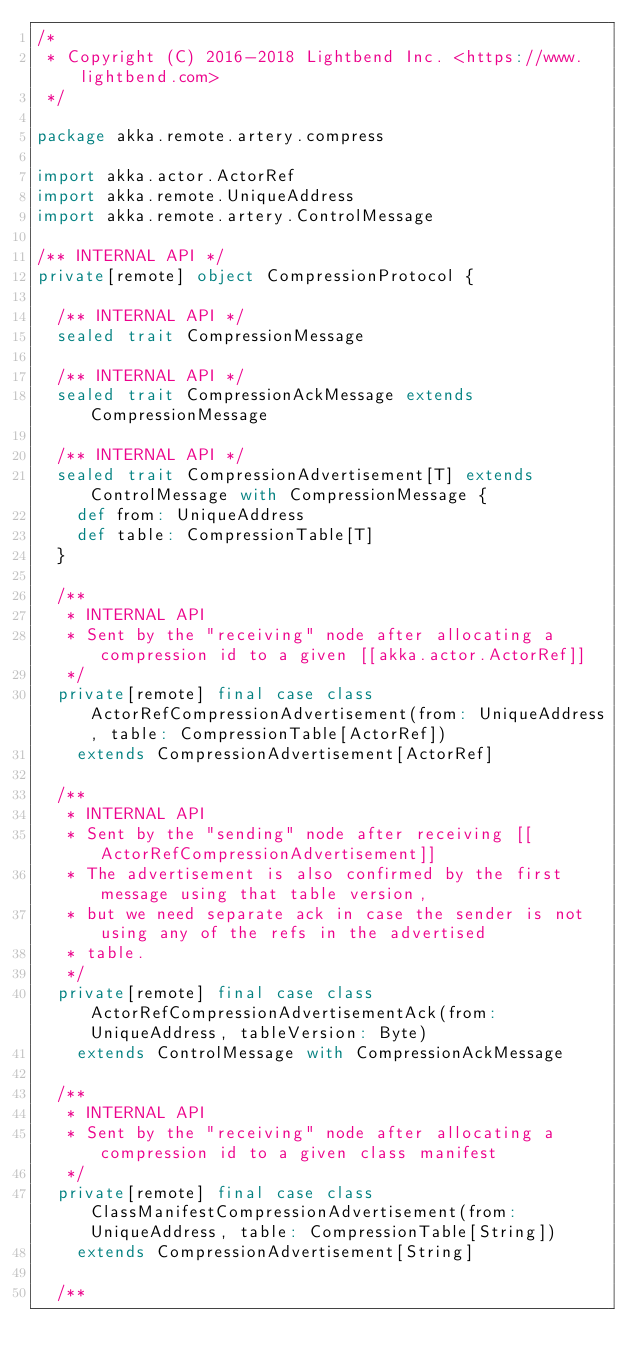Convert code to text. <code><loc_0><loc_0><loc_500><loc_500><_Scala_>/*
 * Copyright (C) 2016-2018 Lightbend Inc. <https://www.lightbend.com>
 */

package akka.remote.artery.compress

import akka.actor.ActorRef
import akka.remote.UniqueAddress
import akka.remote.artery.ControlMessage

/** INTERNAL API */
private[remote] object CompressionProtocol {

  /** INTERNAL API */
  sealed trait CompressionMessage

  /** INTERNAL API */
  sealed trait CompressionAckMessage extends CompressionMessage

  /** INTERNAL API */
  sealed trait CompressionAdvertisement[T] extends ControlMessage with CompressionMessage {
    def from: UniqueAddress
    def table: CompressionTable[T]
  }

  /**
   * INTERNAL API
   * Sent by the "receiving" node after allocating a compression id to a given [[akka.actor.ActorRef]]
   */
  private[remote] final case class ActorRefCompressionAdvertisement(from: UniqueAddress, table: CompressionTable[ActorRef])
    extends CompressionAdvertisement[ActorRef]

  /**
   * INTERNAL API
   * Sent by the "sending" node after receiving [[ActorRefCompressionAdvertisement]]
   * The advertisement is also confirmed by the first message using that table version,
   * but we need separate ack in case the sender is not using any of the refs in the advertised
   * table.
   */
  private[remote] final case class ActorRefCompressionAdvertisementAck(from: UniqueAddress, tableVersion: Byte)
    extends ControlMessage with CompressionAckMessage

  /**
   * INTERNAL API
   * Sent by the "receiving" node after allocating a compression id to a given class manifest
   */
  private[remote] final case class ClassManifestCompressionAdvertisement(from: UniqueAddress, table: CompressionTable[String])
    extends CompressionAdvertisement[String]

  /**</code> 